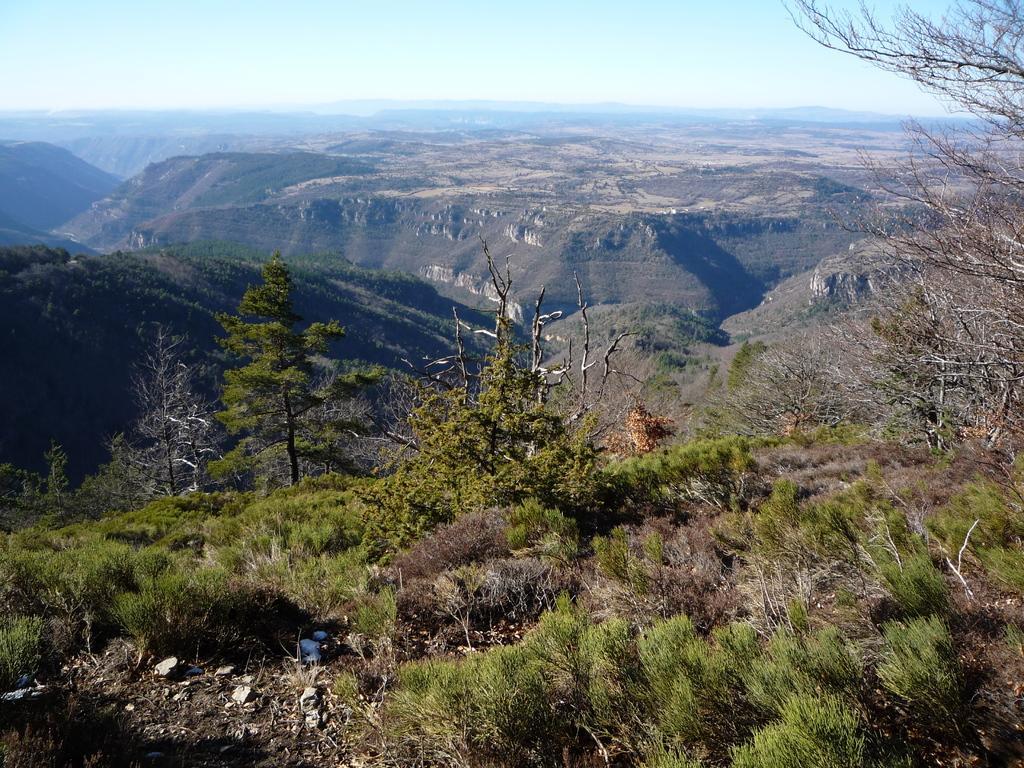Can you describe this image briefly? In this picture we can observe some plants and trees. There are hills. In the background we can observe a sky. 